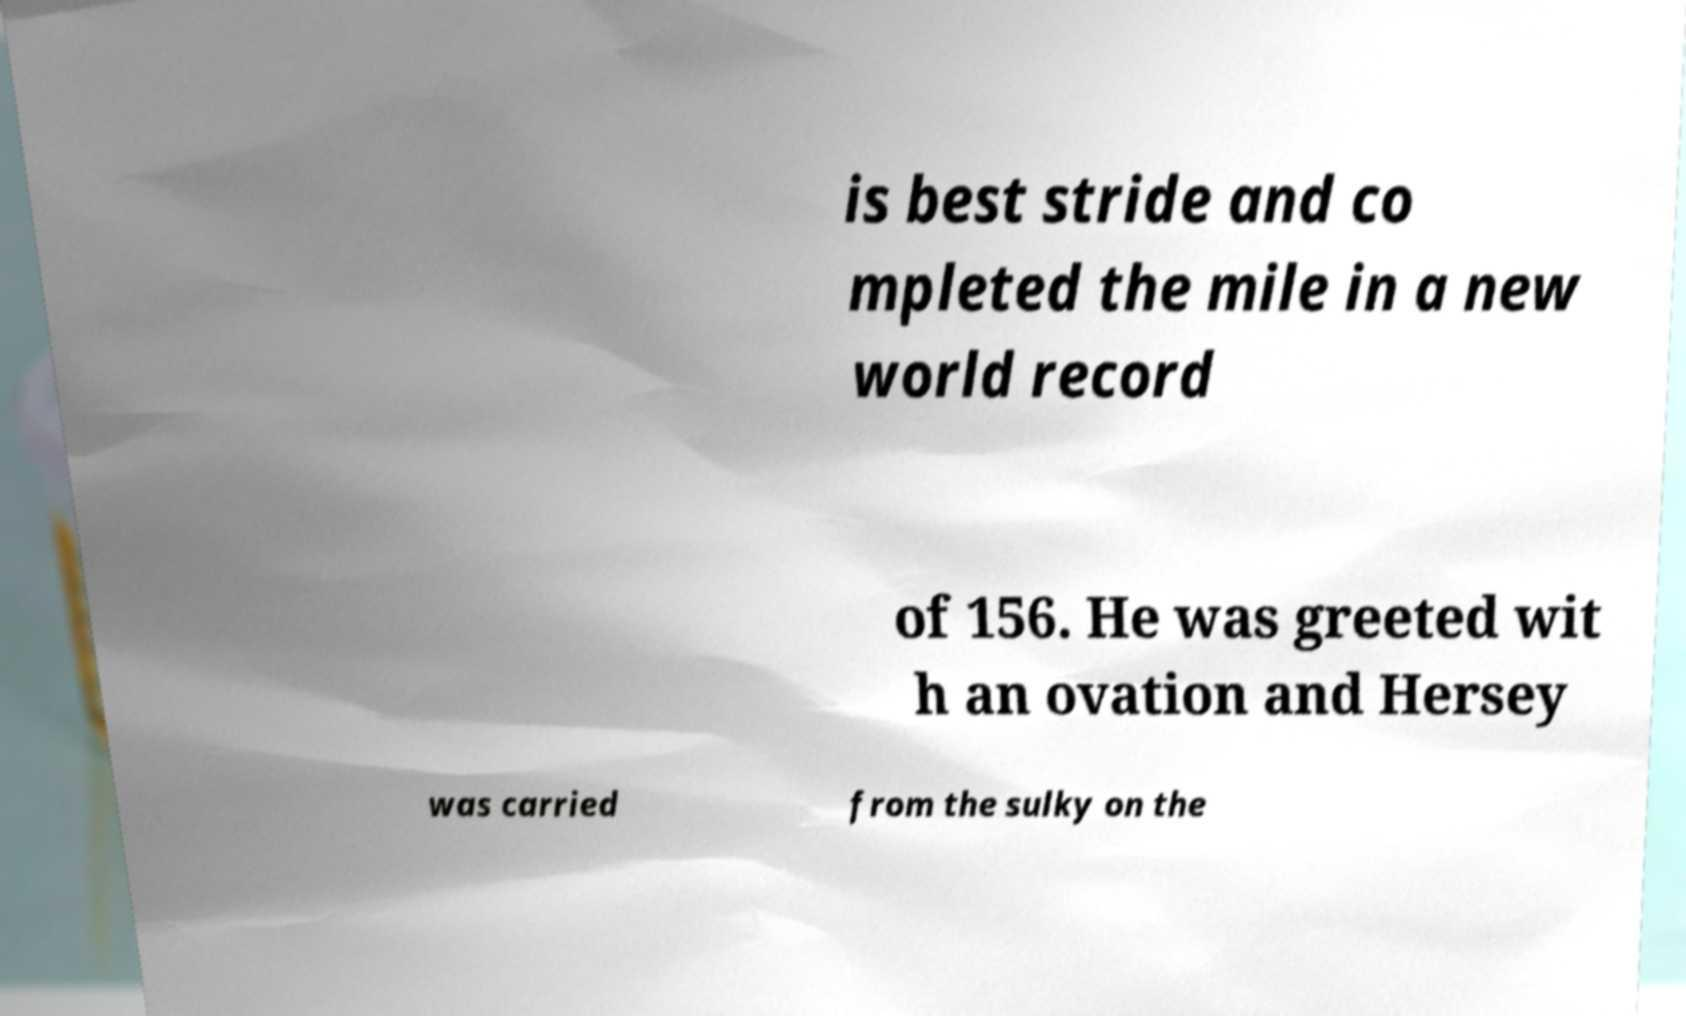Please read and relay the text visible in this image. What does it say? is best stride and co mpleted the mile in a new world record of 156. He was greeted wit h an ovation and Hersey was carried from the sulky on the 